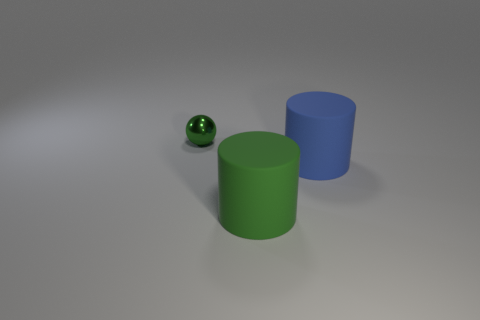Add 1 matte objects. How many objects exist? 4 Subtract all balls. How many objects are left? 2 Add 2 large blue rubber balls. How many large blue rubber balls exist? 2 Subtract 0 blue cubes. How many objects are left? 3 Subtract all green cylinders. Subtract all big green rubber things. How many objects are left? 1 Add 2 small objects. How many small objects are left? 3 